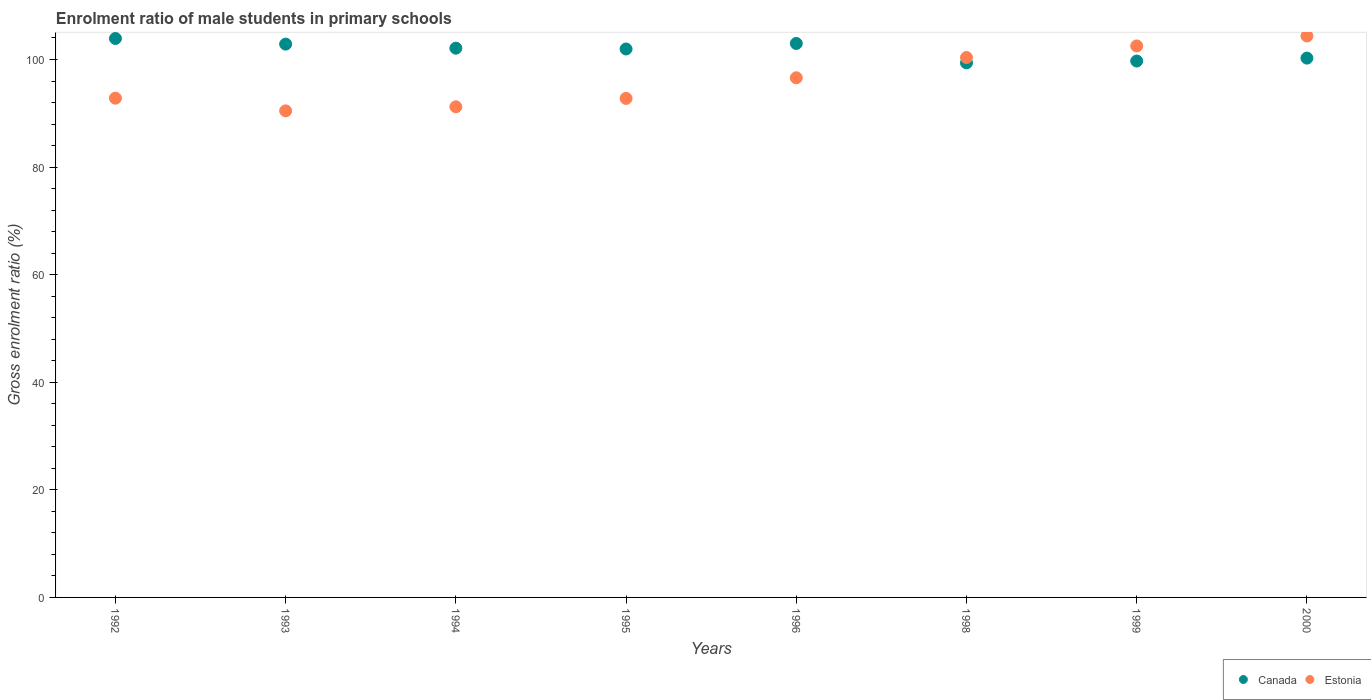How many different coloured dotlines are there?
Provide a succinct answer. 2. Is the number of dotlines equal to the number of legend labels?
Your answer should be compact. Yes. What is the enrolment ratio of male students in primary schools in Canada in 1999?
Ensure brevity in your answer.  99.72. Across all years, what is the maximum enrolment ratio of male students in primary schools in Canada?
Your answer should be very brief. 103.91. Across all years, what is the minimum enrolment ratio of male students in primary schools in Canada?
Ensure brevity in your answer.  99.37. In which year was the enrolment ratio of male students in primary schools in Canada minimum?
Make the answer very short. 1998. What is the total enrolment ratio of male students in primary schools in Estonia in the graph?
Give a very brief answer. 771.11. What is the difference between the enrolment ratio of male students in primary schools in Canada in 1992 and that in 1995?
Provide a short and direct response. 1.95. What is the difference between the enrolment ratio of male students in primary schools in Estonia in 1993 and the enrolment ratio of male students in primary schools in Canada in 1998?
Provide a succinct answer. -8.92. What is the average enrolment ratio of male students in primary schools in Estonia per year?
Your answer should be compact. 96.39. In the year 1995, what is the difference between the enrolment ratio of male students in primary schools in Canada and enrolment ratio of male students in primary schools in Estonia?
Offer a very short reply. 9.19. What is the ratio of the enrolment ratio of male students in primary schools in Estonia in 1992 to that in 1998?
Offer a terse response. 0.92. What is the difference between the highest and the second highest enrolment ratio of male students in primary schools in Estonia?
Keep it short and to the point. 1.85. What is the difference between the highest and the lowest enrolment ratio of male students in primary schools in Canada?
Your response must be concise. 4.53. In how many years, is the enrolment ratio of male students in primary schools in Canada greater than the average enrolment ratio of male students in primary schools in Canada taken over all years?
Provide a short and direct response. 5. Does the enrolment ratio of male students in primary schools in Estonia monotonically increase over the years?
Make the answer very short. No. Is the enrolment ratio of male students in primary schools in Estonia strictly greater than the enrolment ratio of male students in primary schools in Canada over the years?
Give a very brief answer. No. How many years are there in the graph?
Keep it short and to the point. 8. What is the difference between two consecutive major ticks on the Y-axis?
Your answer should be very brief. 20. Does the graph contain any zero values?
Your response must be concise. No. Does the graph contain grids?
Give a very brief answer. No. Where does the legend appear in the graph?
Provide a short and direct response. Bottom right. How many legend labels are there?
Provide a succinct answer. 2. What is the title of the graph?
Your answer should be very brief. Enrolment ratio of male students in primary schools. What is the label or title of the X-axis?
Make the answer very short. Years. What is the Gross enrolment ratio (%) of Canada in 1992?
Keep it short and to the point. 103.91. What is the Gross enrolment ratio (%) in Estonia in 1992?
Your response must be concise. 92.81. What is the Gross enrolment ratio (%) of Canada in 1993?
Make the answer very short. 102.86. What is the Gross enrolment ratio (%) of Estonia in 1993?
Ensure brevity in your answer.  90.46. What is the Gross enrolment ratio (%) in Canada in 1994?
Ensure brevity in your answer.  102.1. What is the Gross enrolment ratio (%) of Estonia in 1994?
Keep it short and to the point. 91.21. What is the Gross enrolment ratio (%) of Canada in 1995?
Make the answer very short. 101.96. What is the Gross enrolment ratio (%) in Estonia in 1995?
Offer a very short reply. 92.77. What is the Gross enrolment ratio (%) in Canada in 1996?
Ensure brevity in your answer.  102.98. What is the Gross enrolment ratio (%) of Estonia in 1996?
Ensure brevity in your answer.  96.6. What is the Gross enrolment ratio (%) of Canada in 1998?
Make the answer very short. 99.37. What is the Gross enrolment ratio (%) of Estonia in 1998?
Your answer should be very brief. 100.37. What is the Gross enrolment ratio (%) of Canada in 1999?
Offer a very short reply. 99.72. What is the Gross enrolment ratio (%) in Estonia in 1999?
Keep it short and to the point. 102.52. What is the Gross enrolment ratio (%) in Canada in 2000?
Make the answer very short. 100.26. What is the Gross enrolment ratio (%) in Estonia in 2000?
Your answer should be very brief. 104.37. Across all years, what is the maximum Gross enrolment ratio (%) of Canada?
Keep it short and to the point. 103.91. Across all years, what is the maximum Gross enrolment ratio (%) of Estonia?
Your response must be concise. 104.37. Across all years, what is the minimum Gross enrolment ratio (%) of Canada?
Provide a short and direct response. 99.37. Across all years, what is the minimum Gross enrolment ratio (%) of Estonia?
Offer a very short reply. 90.46. What is the total Gross enrolment ratio (%) in Canada in the graph?
Offer a terse response. 813.16. What is the total Gross enrolment ratio (%) of Estonia in the graph?
Your response must be concise. 771.11. What is the difference between the Gross enrolment ratio (%) of Canada in 1992 and that in 1993?
Your answer should be compact. 1.04. What is the difference between the Gross enrolment ratio (%) of Estonia in 1992 and that in 1993?
Keep it short and to the point. 2.36. What is the difference between the Gross enrolment ratio (%) of Canada in 1992 and that in 1994?
Your answer should be very brief. 1.8. What is the difference between the Gross enrolment ratio (%) in Estonia in 1992 and that in 1994?
Keep it short and to the point. 1.6. What is the difference between the Gross enrolment ratio (%) of Canada in 1992 and that in 1995?
Give a very brief answer. 1.95. What is the difference between the Gross enrolment ratio (%) in Estonia in 1992 and that in 1995?
Ensure brevity in your answer.  0.05. What is the difference between the Gross enrolment ratio (%) in Canada in 1992 and that in 1996?
Your response must be concise. 0.93. What is the difference between the Gross enrolment ratio (%) of Estonia in 1992 and that in 1996?
Offer a terse response. -3.79. What is the difference between the Gross enrolment ratio (%) in Canada in 1992 and that in 1998?
Your answer should be compact. 4.53. What is the difference between the Gross enrolment ratio (%) of Estonia in 1992 and that in 1998?
Keep it short and to the point. -7.56. What is the difference between the Gross enrolment ratio (%) of Canada in 1992 and that in 1999?
Your answer should be compact. 4.19. What is the difference between the Gross enrolment ratio (%) in Estonia in 1992 and that in 1999?
Keep it short and to the point. -9.71. What is the difference between the Gross enrolment ratio (%) of Canada in 1992 and that in 2000?
Ensure brevity in your answer.  3.65. What is the difference between the Gross enrolment ratio (%) of Estonia in 1992 and that in 2000?
Provide a succinct answer. -11.56. What is the difference between the Gross enrolment ratio (%) in Canada in 1993 and that in 1994?
Keep it short and to the point. 0.76. What is the difference between the Gross enrolment ratio (%) of Estonia in 1993 and that in 1994?
Provide a short and direct response. -0.75. What is the difference between the Gross enrolment ratio (%) of Canada in 1993 and that in 1995?
Provide a short and direct response. 0.91. What is the difference between the Gross enrolment ratio (%) in Estonia in 1993 and that in 1995?
Offer a terse response. -2.31. What is the difference between the Gross enrolment ratio (%) of Canada in 1993 and that in 1996?
Make the answer very short. -0.12. What is the difference between the Gross enrolment ratio (%) of Estonia in 1993 and that in 1996?
Make the answer very short. -6.14. What is the difference between the Gross enrolment ratio (%) of Canada in 1993 and that in 1998?
Your answer should be compact. 3.49. What is the difference between the Gross enrolment ratio (%) in Estonia in 1993 and that in 1998?
Keep it short and to the point. -9.92. What is the difference between the Gross enrolment ratio (%) in Canada in 1993 and that in 1999?
Give a very brief answer. 3.15. What is the difference between the Gross enrolment ratio (%) in Estonia in 1993 and that in 1999?
Provide a short and direct response. -12.06. What is the difference between the Gross enrolment ratio (%) of Canada in 1993 and that in 2000?
Your answer should be compact. 2.6. What is the difference between the Gross enrolment ratio (%) in Estonia in 1993 and that in 2000?
Provide a succinct answer. -13.91. What is the difference between the Gross enrolment ratio (%) of Canada in 1994 and that in 1995?
Give a very brief answer. 0.15. What is the difference between the Gross enrolment ratio (%) in Estonia in 1994 and that in 1995?
Your response must be concise. -1.56. What is the difference between the Gross enrolment ratio (%) of Canada in 1994 and that in 1996?
Your answer should be very brief. -0.88. What is the difference between the Gross enrolment ratio (%) in Estonia in 1994 and that in 1996?
Offer a terse response. -5.39. What is the difference between the Gross enrolment ratio (%) in Canada in 1994 and that in 1998?
Your answer should be very brief. 2.73. What is the difference between the Gross enrolment ratio (%) of Estonia in 1994 and that in 1998?
Your response must be concise. -9.16. What is the difference between the Gross enrolment ratio (%) of Canada in 1994 and that in 1999?
Give a very brief answer. 2.39. What is the difference between the Gross enrolment ratio (%) of Estonia in 1994 and that in 1999?
Offer a terse response. -11.31. What is the difference between the Gross enrolment ratio (%) in Canada in 1994 and that in 2000?
Make the answer very short. 1.85. What is the difference between the Gross enrolment ratio (%) in Estonia in 1994 and that in 2000?
Make the answer very short. -13.16. What is the difference between the Gross enrolment ratio (%) in Canada in 1995 and that in 1996?
Your answer should be compact. -1.03. What is the difference between the Gross enrolment ratio (%) of Estonia in 1995 and that in 1996?
Keep it short and to the point. -3.83. What is the difference between the Gross enrolment ratio (%) of Canada in 1995 and that in 1998?
Your response must be concise. 2.58. What is the difference between the Gross enrolment ratio (%) of Estonia in 1995 and that in 1998?
Offer a very short reply. -7.61. What is the difference between the Gross enrolment ratio (%) of Canada in 1995 and that in 1999?
Your answer should be compact. 2.24. What is the difference between the Gross enrolment ratio (%) in Estonia in 1995 and that in 1999?
Your answer should be compact. -9.75. What is the difference between the Gross enrolment ratio (%) of Canada in 1995 and that in 2000?
Provide a short and direct response. 1.7. What is the difference between the Gross enrolment ratio (%) in Estonia in 1995 and that in 2000?
Your response must be concise. -11.6. What is the difference between the Gross enrolment ratio (%) in Canada in 1996 and that in 1998?
Offer a terse response. 3.61. What is the difference between the Gross enrolment ratio (%) of Estonia in 1996 and that in 1998?
Provide a succinct answer. -3.77. What is the difference between the Gross enrolment ratio (%) in Canada in 1996 and that in 1999?
Your response must be concise. 3.26. What is the difference between the Gross enrolment ratio (%) in Estonia in 1996 and that in 1999?
Your response must be concise. -5.92. What is the difference between the Gross enrolment ratio (%) in Canada in 1996 and that in 2000?
Make the answer very short. 2.72. What is the difference between the Gross enrolment ratio (%) in Estonia in 1996 and that in 2000?
Provide a short and direct response. -7.77. What is the difference between the Gross enrolment ratio (%) of Canada in 1998 and that in 1999?
Ensure brevity in your answer.  -0.34. What is the difference between the Gross enrolment ratio (%) of Estonia in 1998 and that in 1999?
Ensure brevity in your answer.  -2.15. What is the difference between the Gross enrolment ratio (%) in Canada in 1998 and that in 2000?
Make the answer very short. -0.88. What is the difference between the Gross enrolment ratio (%) of Estonia in 1998 and that in 2000?
Ensure brevity in your answer.  -4. What is the difference between the Gross enrolment ratio (%) in Canada in 1999 and that in 2000?
Your answer should be compact. -0.54. What is the difference between the Gross enrolment ratio (%) in Estonia in 1999 and that in 2000?
Make the answer very short. -1.85. What is the difference between the Gross enrolment ratio (%) of Canada in 1992 and the Gross enrolment ratio (%) of Estonia in 1993?
Your answer should be compact. 13.45. What is the difference between the Gross enrolment ratio (%) of Canada in 1992 and the Gross enrolment ratio (%) of Estonia in 1994?
Ensure brevity in your answer.  12.7. What is the difference between the Gross enrolment ratio (%) of Canada in 1992 and the Gross enrolment ratio (%) of Estonia in 1995?
Keep it short and to the point. 11.14. What is the difference between the Gross enrolment ratio (%) in Canada in 1992 and the Gross enrolment ratio (%) in Estonia in 1996?
Make the answer very short. 7.31. What is the difference between the Gross enrolment ratio (%) in Canada in 1992 and the Gross enrolment ratio (%) in Estonia in 1998?
Your answer should be compact. 3.53. What is the difference between the Gross enrolment ratio (%) of Canada in 1992 and the Gross enrolment ratio (%) of Estonia in 1999?
Give a very brief answer. 1.39. What is the difference between the Gross enrolment ratio (%) of Canada in 1992 and the Gross enrolment ratio (%) of Estonia in 2000?
Offer a very short reply. -0.46. What is the difference between the Gross enrolment ratio (%) of Canada in 1993 and the Gross enrolment ratio (%) of Estonia in 1994?
Provide a short and direct response. 11.65. What is the difference between the Gross enrolment ratio (%) in Canada in 1993 and the Gross enrolment ratio (%) in Estonia in 1995?
Offer a terse response. 10.09. What is the difference between the Gross enrolment ratio (%) of Canada in 1993 and the Gross enrolment ratio (%) of Estonia in 1996?
Provide a succinct answer. 6.26. What is the difference between the Gross enrolment ratio (%) in Canada in 1993 and the Gross enrolment ratio (%) in Estonia in 1998?
Your answer should be very brief. 2.49. What is the difference between the Gross enrolment ratio (%) in Canada in 1993 and the Gross enrolment ratio (%) in Estonia in 1999?
Provide a succinct answer. 0.34. What is the difference between the Gross enrolment ratio (%) of Canada in 1993 and the Gross enrolment ratio (%) of Estonia in 2000?
Make the answer very short. -1.51. What is the difference between the Gross enrolment ratio (%) in Canada in 1994 and the Gross enrolment ratio (%) in Estonia in 1995?
Provide a succinct answer. 9.34. What is the difference between the Gross enrolment ratio (%) in Canada in 1994 and the Gross enrolment ratio (%) in Estonia in 1996?
Ensure brevity in your answer.  5.5. What is the difference between the Gross enrolment ratio (%) in Canada in 1994 and the Gross enrolment ratio (%) in Estonia in 1998?
Make the answer very short. 1.73. What is the difference between the Gross enrolment ratio (%) of Canada in 1994 and the Gross enrolment ratio (%) of Estonia in 1999?
Provide a succinct answer. -0.42. What is the difference between the Gross enrolment ratio (%) of Canada in 1994 and the Gross enrolment ratio (%) of Estonia in 2000?
Your answer should be very brief. -2.27. What is the difference between the Gross enrolment ratio (%) in Canada in 1995 and the Gross enrolment ratio (%) in Estonia in 1996?
Keep it short and to the point. 5.36. What is the difference between the Gross enrolment ratio (%) of Canada in 1995 and the Gross enrolment ratio (%) of Estonia in 1998?
Keep it short and to the point. 1.58. What is the difference between the Gross enrolment ratio (%) of Canada in 1995 and the Gross enrolment ratio (%) of Estonia in 1999?
Make the answer very short. -0.56. What is the difference between the Gross enrolment ratio (%) in Canada in 1995 and the Gross enrolment ratio (%) in Estonia in 2000?
Provide a succinct answer. -2.42. What is the difference between the Gross enrolment ratio (%) of Canada in 1996 and the Gross enrolment ratio (%) of Estonia in 1998?
Your answer should be compact. 2.61. What is the difference between the Gross enrolment ratio (%) in Canada in 1996 and the Gross enrolment ratio (%) in Estonia in 1999?
Your answer should be compact. 0.46. What is the difference between the Gross enrolment ratio (%) in Canada in 1996 and the Gross enrolment ratio (%) in Estonia in 2000?
Provide a succinct answer. -1.39. What is the difference between the Gross enrolment ratio (%) in Canada in 1998 and the Gross enrolment ratio (%) in Estonia in 1999?
Make the answer very short. -3.15. What is the difference between the Gross enrolment ratio (%) of Canada in 1998 and the Gross enrolment ratio (%) of Estonia in 2000?
Provide a succinct answer. -5. What is the difference between the Gross enrolment ratio (%) of Canada in 1999 and the Gross enrolment ratio (%) of Estonia in 2000?
Give a very brief answer. -4.65. What is the average Gross enrolment ratio (%) of Canada per year?
Keep it short and to the point. 101.65. What is the average Gross enrolment ratio (%) in Estonia per year?
Give a very brief answer. 96.39. In the year 1992, what is the difference between the Gross enrolment ratio (%) of Canada and Gross enrolment ratio (%) of Estonia?
Your answer should be very brief. 11.09. In the year 1993, what is the difference between the Gross enrolment ratio (%) of Canada and Gross enrolment ratio (%) of Estonia?
Provide a succinct answer. 12.41. In the year 1994, what is the difference between the Gross enrolment ratio (%) in Canada and Gross enrolment ratio (%) in Estonia?
Your answer should be very brief. 10.89. In the year 1995, what is the difference between the Gross enrolment ratio (%) of Canada and Gross enrolment ratio (%) of Estonia?
Make the answer very short. 9.19. In the year 1996, what is the difference between the Gross enrolment ratio (%) in Canada and Gross enrolment ratio (%) in Estonia?
Your answer should be very brief. 6.38. In the year 1998, what is the difference between the Gross enrolment ratio (%) in Canada and Gross enrolment ratio (%) in Estonia?
Offer a very short reply. -1. In the year 1999, what is the difference between the Gross enrolment ratio (%) of Canada and Gross enrolment ratio (%) of Estonia?
Offer a very short reply. -2.8. In the year 2000, what is the difference between the Gross enrolment ratio (%) of Canada and Gross enrolment ratio (%) of Estonia?
Your answer should be compact. -4.11. What is the ratio of the Gross enrolment ratio (%) of Canada in 1992 to that in 1993?
Your answer should be very brief. 1.01. What is the ratio of the Gross enrolment ratio (%) of Estonia in 1992 to that in 1993?
Provide a short and direct response. 1.03. What is the ratio of the Gross enrolment ratio (%) of Canada in 1992 to that in 1994?
Your answer should be compact. 1.02. What is the ratio of the Gross enrolment ratio (%) in Estonia in 1992 to that in 1994?
Ensure brevity in your answer.  1.02. What is the ratio of the Gross enrolment ratio (%) of Canada in 1992 to that in 1995?
Your answer should be very brief. 1.02. What is the ratio of the Gross enrolment ratio (%) of Estonia in 1992 to that in 1995?
Ensure brevity in your answer.  1. What is the ratio of the Gross enrolment ratio (%) in Canada in 1992 to that in 1996?
Provide a short and direct response. 1.01. What is the ratio of the Gross enrolment ratio (%) in Estonia in 1992 to that in 1996?
Your answer should be compact. 0.96. What is the ratio of the Gross enrolment ratio (%) of Canada in 1992 to that in 1998?
Provide a succinct answer. 1.05. What is the ratio of the Gross enrolment ratio (%) of Estonia in 1992 to that in 1998?
Offer a terse response. 0.92. What is the ratio of the Gross enrolment ratio (%) of Canada in 1992 to that in 1999?
Provide a succinct answer. 1.04. What is the ratio of the Gross enrolment ratio (%) in Estonia in 1992 to that in 1999?
Make the answer very short. 0.91. What is the ratio of the Gross enrolment ratio (%) of Canada in 1992 to that in 2000?
Keep it short and to the point. 1.04. What is the ratio of the Gross enrolment ratio (%) of Estonia in 1992 to that in 2000?
Offer a very short reply. 0.89. What is the ratio of the Gross enrolment ratio (%) of Canada in 1993 to that in 1994?
Your response must be concise. 1.01. What is the ratio of the Gross enrolment ratio (%) in Estonia in 1993 to that in 1994?
Keep it short and to the point. 0.99. What is the ratio of the Gross enrolment ratio (%) in Canada in 1993 to that in 1995?
Give a very brief answer. 1.01. What is the ratio of the Gross enrolment ratio (%) in Estonia in 1993 to that in 1995?
Give a very brief answer. 0.98. What is the ratio of the Gross enrolment ratio (%) in Estonia in 1993 to that in 1996?
Provide a short and direct response. 0.94. What is the ratio of the Gross enrolment ratio (%) in Canada in 1993 to that in 1998?
Provide a short and direct response. 1.04. What is the ratio of the Gross enrolment ratio (%) of Estonia in 1993 to that in 1998?
Offer a terse response. 0.9. What is the ratio of the Gross enrolment ratio (%) of Canada in 1993 to that in 1999?
Your answer should be compact. 1.03. What is the ratio of the Gross enrolment ratio (%) in Estonia in 1993 to that in 1999?
Offer a terse response. 0.88. What is the ratio of the Gross enrolment ratio (%) of Canada in 1993 to that in 2000?
Your answer should be compact. 1.03. What is the ratio of the Gross enrolment ratio (%) in Estonia in 1993 to that in 2000?
Provide a short and direct response. 0.87. What is the ratio of the Gross enrolment ratio (%) in Estonia in 1994 to that in 1995?
Your answer should be very brief. 0.98. What is the ratio of the Gross enrolment ratio (%) of Estonia in 1994 to that in 1996?
Your response must be concise. 0.94. What is the ratio of the Gross enrolment ratio (%) of Canada in 1994 to that in 1998?
Keep it short and to the point. 1.03. What is the ratio of the Gross enrolment ratio (%) of Estonia in 1994 to that in 1998?
Provide a succinct answer. 0.91. What is the ratio of the Gross enrolment ratio (%) of Canada in 1994 to that in 1999?
Offer a terse response. 1.02. What is the ratio of the Gross enrolment ratio (%) in Estonia in 1994 to that in 1999?
Provide a succinct answer. 0.89. What is the ratio of the Gross enrolment ratio (%) in Canada in 1994 to that in 2000?
Keep it short and to the point. 1.02. What is the ratio of the Gross enrolment ratio (%) of Estonia in 1994 to that in 2000?
Keep it short and to the point. 0.87. What is the ratio of the Gross enrolment ratio (%) in Canada in 1995 to that in 1996?
Your answer should be compact. 0.99. What is the ratio of the Gross enrolment ratio (%) of Estonia in 1995 to that in 1996?
Keep it short and to the point. 0.96. What is the ratio of the Gross enrolment ratio (%) of Canada in 1995 to that in 1998?
Your answer should be compact. 1.03. What is the ratio of the Gross enrolment ratio (%) in Estonia in 1995 to that in 1998?
Your response must be concise. 0.92. What is the ratio of the Gross enrolment ratio (%) in Canada in 1995 to that in 1999?
Give a very brief answer. 1.02. What is the ratio of the Gross enrolment ratio (%) in Estonia in 1995 to that in 1999?
Offer a terse response. 0.9. What is the ratio of the Gross enrolment ratio (%) in Canada in 1995 to that in 2000?
Keep it short and to the point. 1.02. What is the ratio of the Gross enrolment ratio (%) in Estonia in 1995 to that in 2000?
Keep it short and to the point. 0.89. What is the ratio of the Gross enrolment ratio (%) in Canada in 1996 to that in 1998?
Your response must be concise. 1.04. What is the ratio of the Gross enrolment ratio (%) in Estonia in 1996 to that in 1998?
Provide a short and direct response. 0.96. What is the ratio of the Gross enrolment ratio (%) in Canada in 1996 to that in 1999?
Make the answer very short. 1.03. What is the ratio of the Gross enrolment ratio (%) of Estonia in 1996 to that in 1999?
Keep it short and to the point. 0.94. What is the ratio of the Gross enrolment ratio (%) in Canada in 1996 to that in 2000?
Your answer should be very brief. 1.03. What is the ratio of the Gross enrolment ratio (%) of Estonia in 1996 to that in 2000?
Offer a terse response. 0.93. What is the ratio of the Gross enrolment ratio (%) of Canada in 1998 to that in 1999?
Your response must be concise. 1. What is the ratio of the Gross enrolment ratio (%) in Estonia in 1998 to that in 1999?
Provide a succinct answer. 0.98. What is the ratio of the Gross enrolment ratio (%) in Estonia in 1998 to that in 2000?
Keep it short and to the point. 0.96. What is the ratio of the Gross enrolment ratio (%) in Estonia in 1999 to that in 2000?
Offer a terse response. 0.98. What is the difference between the highest and the second highest Gross enrolment ratio (%) of Canada?
Keep it short and to the point. 0.93. What is the difference between the highest and the second highest Gross enrolment ratio (%) in Estonia?
Provide a short and direct response. 1.85. What is the difference between the highest and the lowest Gross enrolment ratio (%) of Canada?
Provide a short and direct response. 4.53. What is the difference between the highest and the lowest Gross enrolment ratio (%) in Estonia?
Keep it short and to the point. 13.91. 